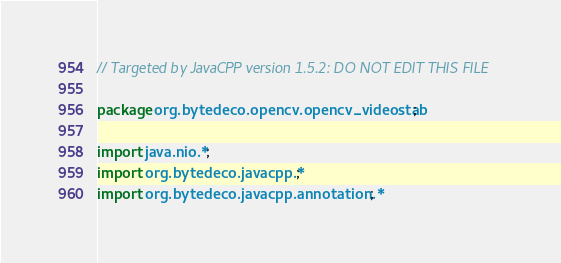Convert code to text. <code><loc_0><loc_0><loc_500><loc_500><_Java_>// Targeted by JavaCPP version 1.5.2: DO NOT EDIT THIS FILE

package org.bytedeco.opencv.opencv_videostab;

import java.nio.*;
import org.bytedeco.javacpp.*;
import org.bytedeco.javacpp.annotation.*;
</code> 